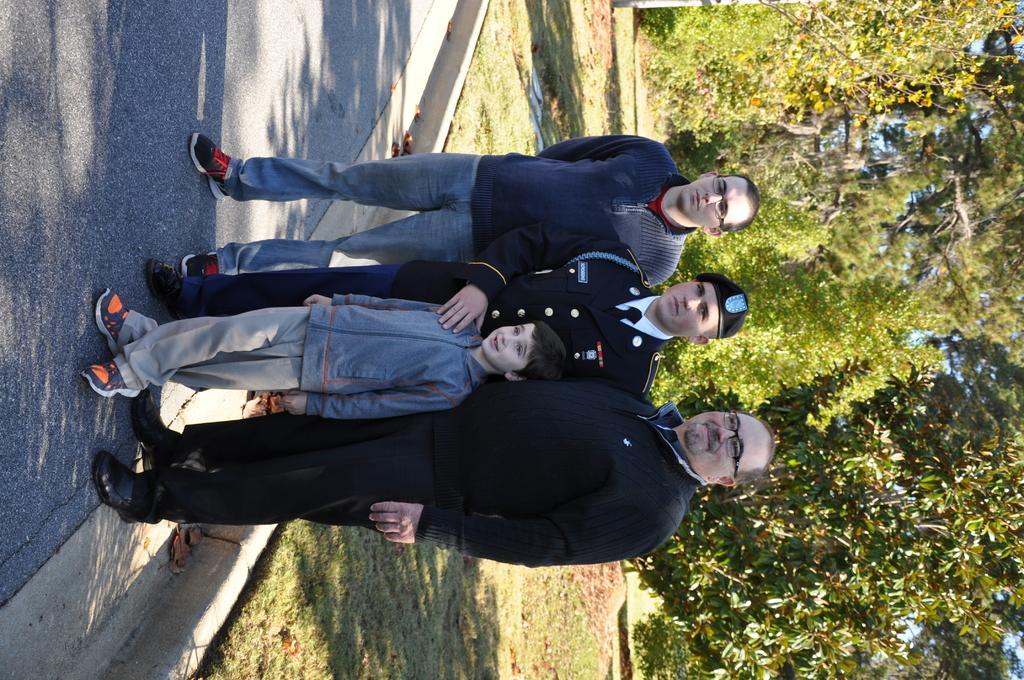Could you give a brief overview of what you see in this image? This picture is clicked outside. In the foreground we can see the group of persons standing on the ground and there is a person wearing uniform and standing on the ground. In the background we can see the grass, trees and some portion of the sky. 